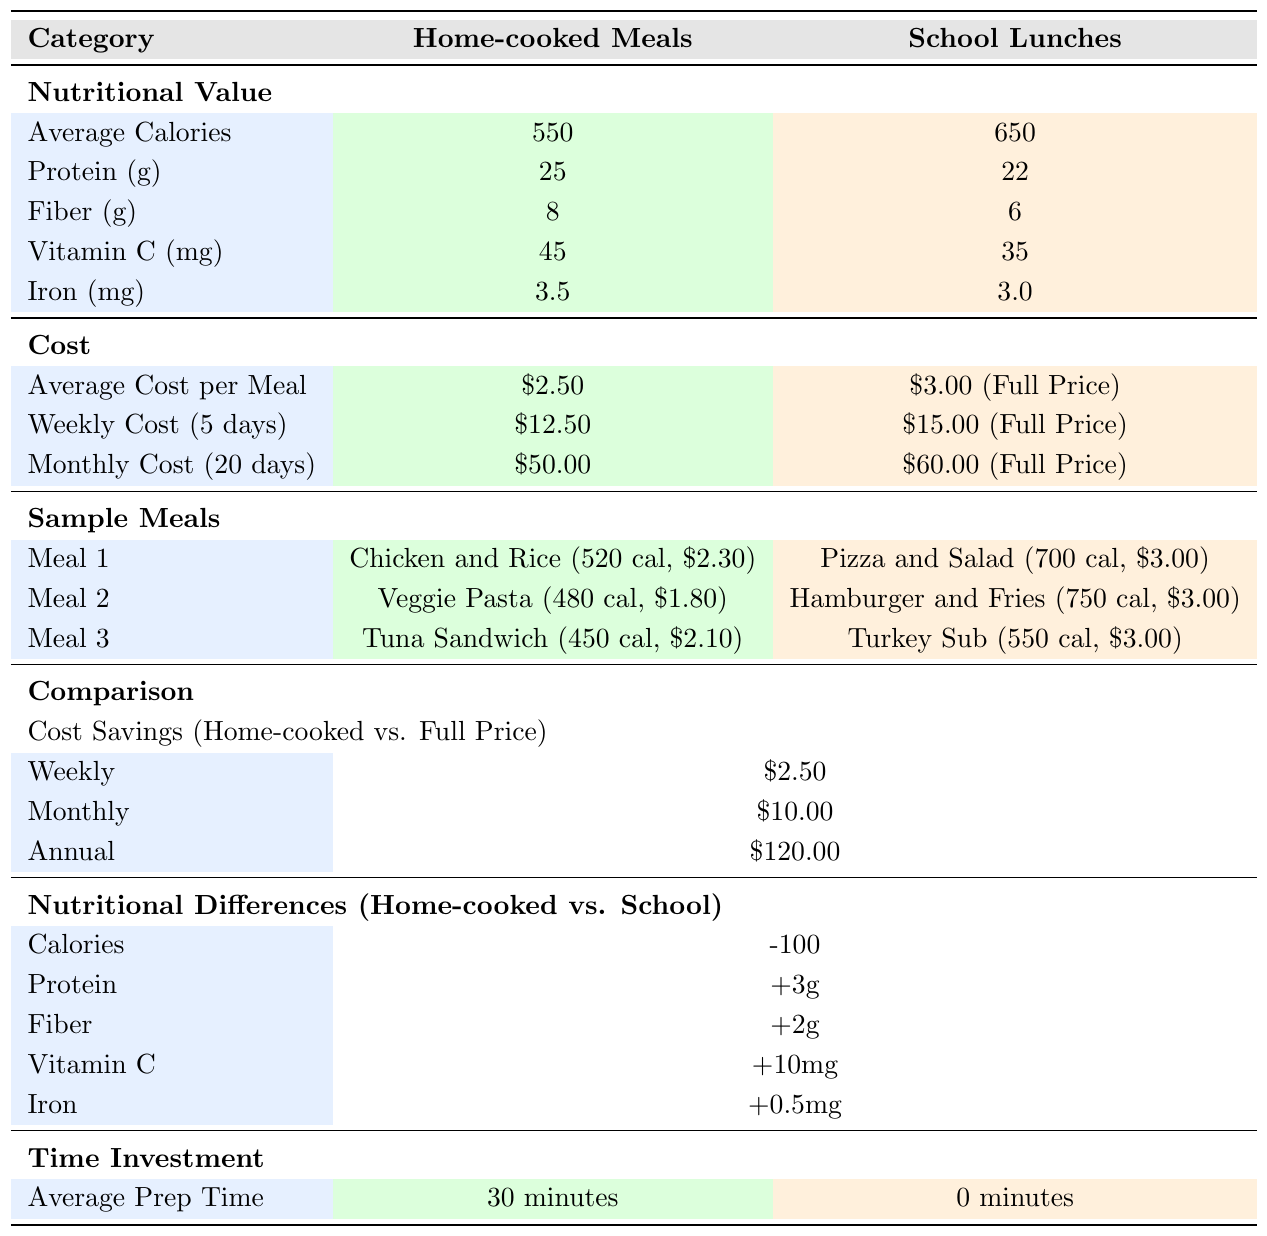What are the average calories in home-cooked meals? The table indicates that home-cooked meals have an average of 550 calories.
Answer: 550 calories What is the weekly cost of home-cooked meals? According to the table, the weekly cost for home-cooked meals for 5 days is $12.50.
Answer: $12.50 Which meal has the highest calories in school lunches? The table lists "Hamburger and Fries" as the school lunch meal with the highest calories at 750.
Answer: 750 calories What is the cost difference between weekly home-cooked meals and full-price school lunches? The weekly cost for home-cooked meals is $12.50, while the full-price school lunch weekly cost is $15.00. The difference is $15.00 - $12.50 = $2.50.
Answer: $2.50 How much does a free school meal cost? The table shows that a free meal costs $0.00.
Answer: $0.00 Are home-cooked meals generally cheaper than school lunches? Yes, as the weekly cost of home-cooked meals is $12.50, while full-price school lunches cost $15.00, making home-cooked meals cheaper.
Answer: Yes What is the average cost per meal for school lunches at full price? The average cost per meal for school lunches at full price is mentioned as $3.00.
Answer: $3.00 What is the calorie difference between home-cooked meals and school lunches? Home-cooked meals provide an average of 550 calories, while school lunches provide 650. The difference is 650 - 550 = -100.
Answer: -100 calories Which type of meal (home-cooked or school lunch) has a higher content of Vitamin C? Home-cooked meals have 45 mg of Vitamin C compared to 35 mg in school lunches, indicating home-cooked meals have a higher Vitamin C content.
Answer: Home-cooked meals How much would I save annually by choosing home-cooked meals over full-price school lunches? The table shows an annual savings of $120.00 by choosing home-cooked meals instead of full-price school lunches.
Answer: $120.00 What nutritional component has a greater difference in favor of home-cooked meals? Home-cooked meals have a higher amount of fiber by 2 grams (8g vs. 6g) when compared to school lunches.
Answer: Fiber How much longer does it take to prepare home-cooked meals compared to school lunches? The average prep time for home-cooked meals is 30 minutes, while school lunches require 0 minutes, meaning it takes 30 minutes longer to prepare home-cooked meals.
Answer: 30 minutes Is the protein content higher in home-cooked meals than in school lunches? Yes, home-cooked meals contain 25g of protein compared to 22g in school lunches, indicating that home-cooked meals have a higher protein content.
Answer: Yes 